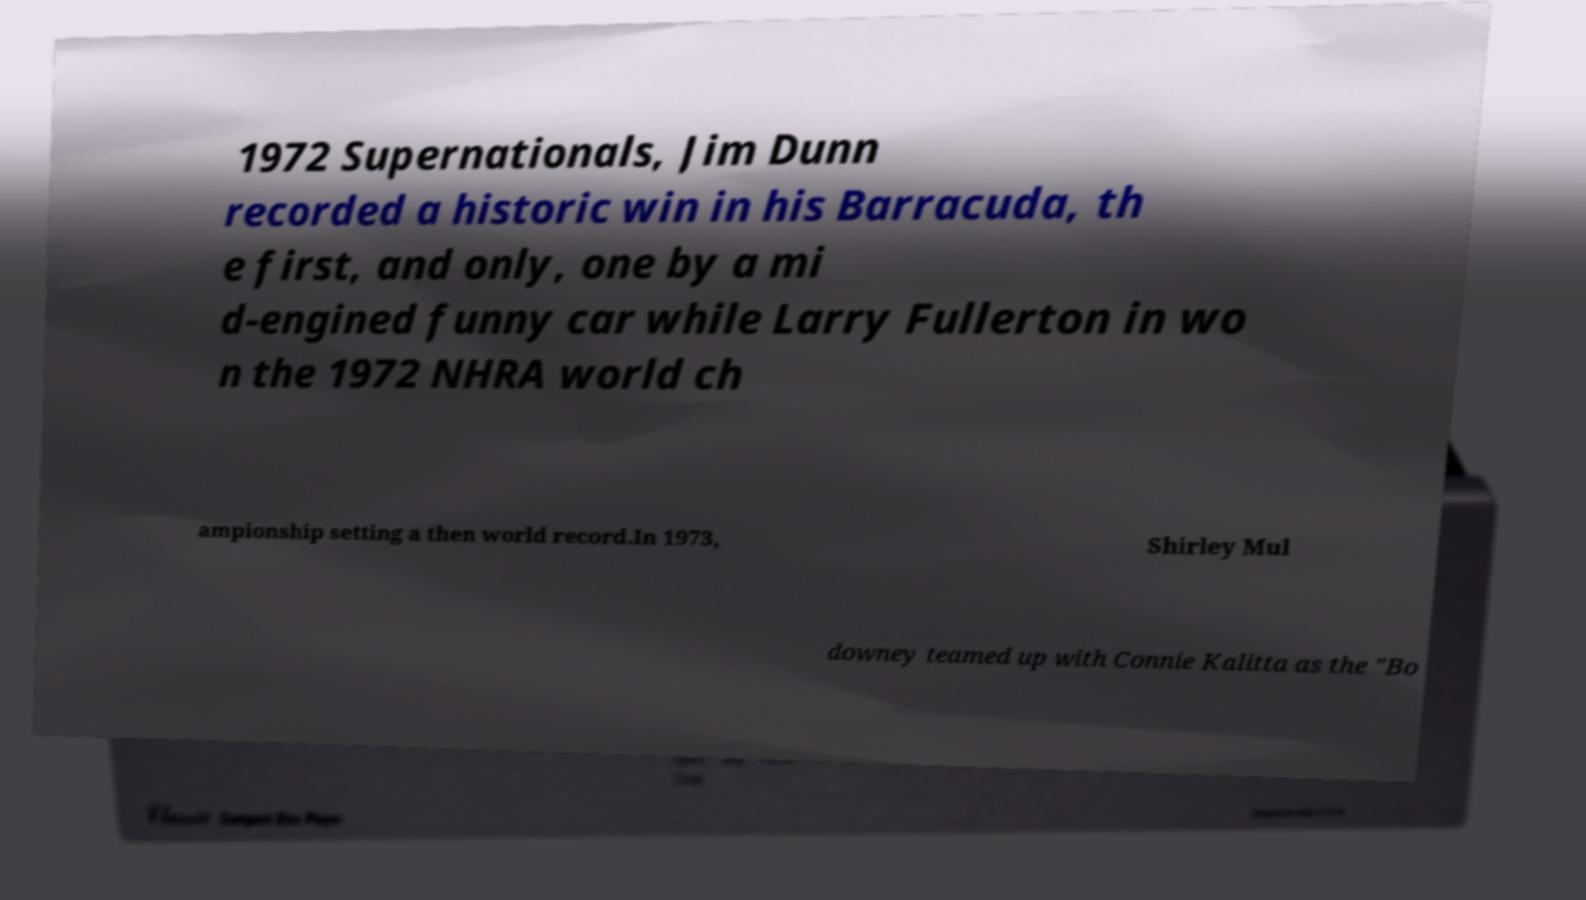I need the written content from this picture converted into text. Can you do that? 1972 Supernationals, Jim Dunn recorded a historic win in his Barracuda, th e first, and only, one by a mi d-engined funny car while Larry Fullerton in wo n the 1972 NHRA world ch ampionship setting a then world record.In 1973, Shirley Mul downey teamed up with Connie Kalitta as the "Bo 